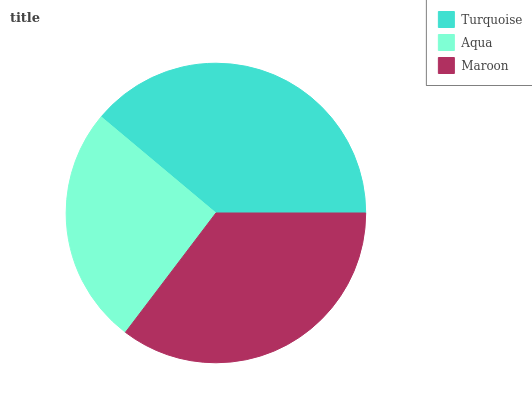Is Aqua the minimum?
Answer yes or no. Yes. Is Turquoise the maximum?
Answer yes or no. Yes. Is Maroon the minimum?
Answer yes or no. No. Is Maroon the maximum?
Answer yes or no. No. Is Maroon greater than Aqua?
Answer yes or no. Yes. Is Aqua less than Maroon?
Answer yes or no. Yes. Is Aqua greater than Maroon?
Answer yes or no. No. Is Maroon less than Aqua?
Answer yes or no. No. Is Maroon the high median?
Answer yes or no. Yes. Is Maroon the low median?
Answer yes or no. Yes. Is Turquoise the high median?
Answer yes or no. No. Is Turquoise the low median?
Answer yes or no. No. 